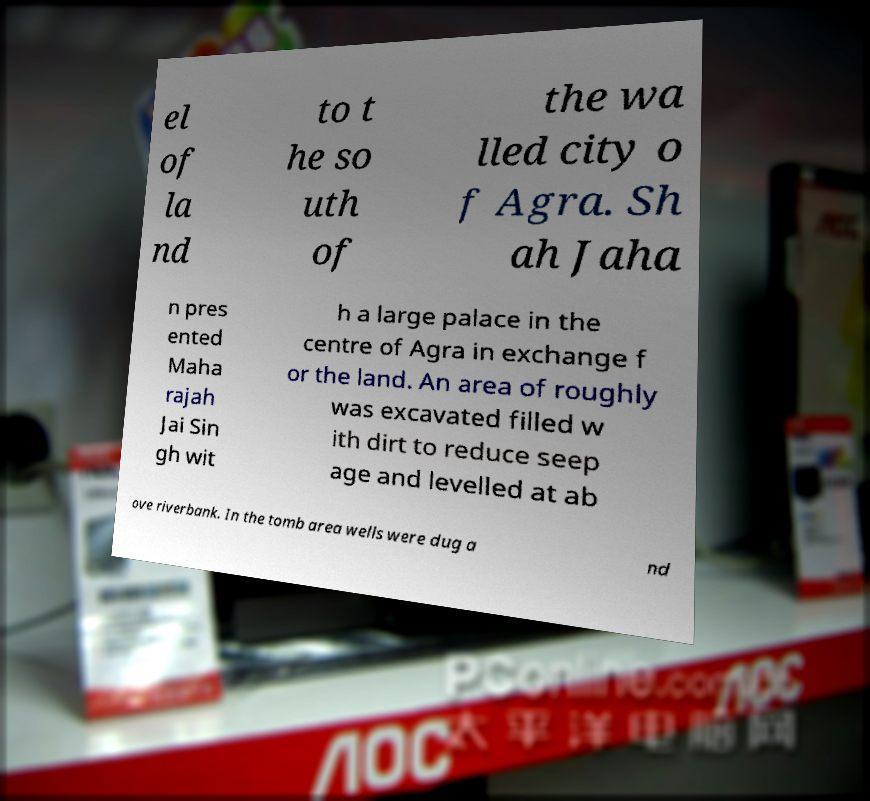Please identify and transcribe the text found in this image. el of la nd to t he so uth of the wa lled city o f Agra. Sh ah Jaha n pres ented Maha rajah Jai Sin gh wit h a large palace in the centre of Agra in exchange f or the land. An area of roughly was excavated filled w ith dirt to reduce seep age and levelled at ab ove riverbank. In the tomb area wells were dug a nd 